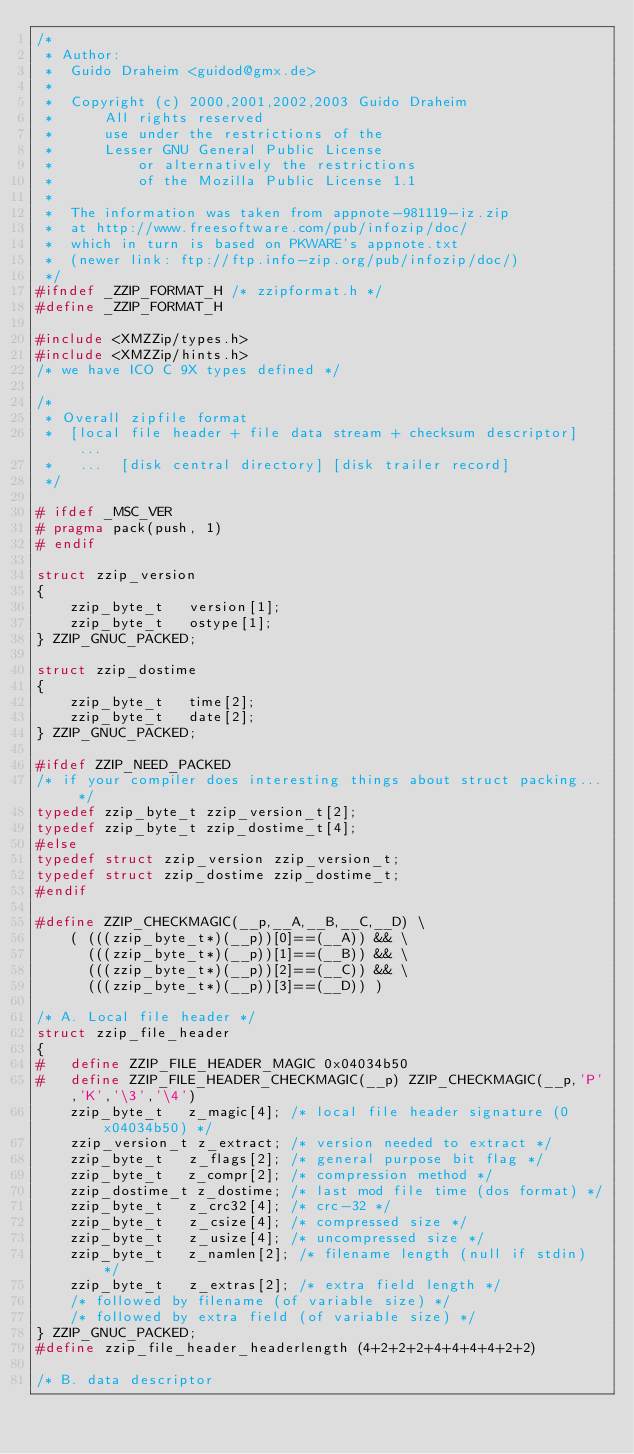Convert code to text. <code><loc_0><loc_0><loc_500><loc_500><_C_>/*
 * Author:
 *	Guido Draheim <guidod@gmx.de>
 *
 *	Copyright (c) 2000,2001,2002,2003 Guido Draheim
 * 	    All rights reserved
 *	    use under the restrictions of the
 *	    Lesser GNU General Public License
 *          or alternatively the restrictions
 *          of the Mozilla Public License 1.1
 *
 *  The information was taken from appnote-981119-iz.zip
 *  at http://www.freesoftware.com/pub/infozip/doc/
 *  which in turn is based on PKWARE's appnote.txt
 *  (newer link: ftp://ftp.info-zip.org/pub/infozip/doc/)
 */
#ifndef _ZZIP_FORMAT_H /* zzipformat.h */
#define _ZZIP_FORMAT_H

#include <XMZZip/types.h>
#include <XMZZip/hints.h>
/* we have ICO C 9X types defined */

/*
 * Overall zipfile format
 *  [local file header + file data stream + checksum descriptor] ...
 *   ...  [disk central directory] [disk trailer record]
 */

# ifdef _MSC_VER
# pragma pack(push, 1)
# endif

struct zzip_version
{
    zzip_byte_t   version[1];
    zzip_byte_t   ostype[1];
} ZZIP_GNUC_PACKED;

struct zzip_dostime
{
    zzip_byte_t   time[2];
    zzip_byte_t   date[2];
} ZZIP_GNUC_PACKED;

#ifdef ZZIP_NEED_PACKED
/* if your compiler does interesting things about struct packing... */
typedef zzip_byte_t zzip_version_t[2];
typedef zzip_byte_t zzip_dostime_t[4];
#else
typedef struct zzip_version zzip_version_t;
typedef struct zzip_dostime zzip_dostime_t;
#endif

#define ZZIP_CHECKMAGIC(__p,__A,__B,__C,__D) \
    ( (((zzip_byte_t*)(__p))[0]==(__A)) && \
      (((zzip_byte_t*)(__p))[1]==(__B)) && \
      (((zzip_byte_t*)(__p))[2]==(__C)) && \
      (((zzip_byte_t*)(__p))[3]==(__D)) )

/* A. Local file header */
struct zzip_file_header
{
#   define ZZIP_FILE_HEADER_MAGIC 0x04034b50
#   define ZZIP_FILE_HEADER_CHECKMAGIC(__p) ZZIP_CHECKMAGIC(__p,'P','K','\3','\4')
    zzip_byte_t   z_magic[4]; /* local file header signature (0x04034b50) */
    zzip_version_t z_extract; /* version needed to extract */
    zzip_byte_t   z_flags[2]; /* general purpose bit flag */
    zzip_byte_t   z_compr[2]; /* compression method */
    zzip_dostime_t z_dostime; /* last mod file time (dos format) */
    zzip_byte_t   z_crc32[4]; /* crc-32 */
    zzip_byte_t   z_csize[4]; /* compressed size */
    zzip_byte_t   z_usize[4]; /* uncompressed size */
    zzip_byte_t   z_namlen[2]; /* filename length (null if stdin) */
    zzip_byte_t   z_extras[2]; /* extra field length */
    /* followed by filename (of variable size) */
    /* followed by extra field (of variable size) */
} ZZIP_GNUC_PACKED;
#define zzip_file_header_headerlength (4+2+2+2+4+4+4+4+2+2)

/* B. data descriptor</code> 